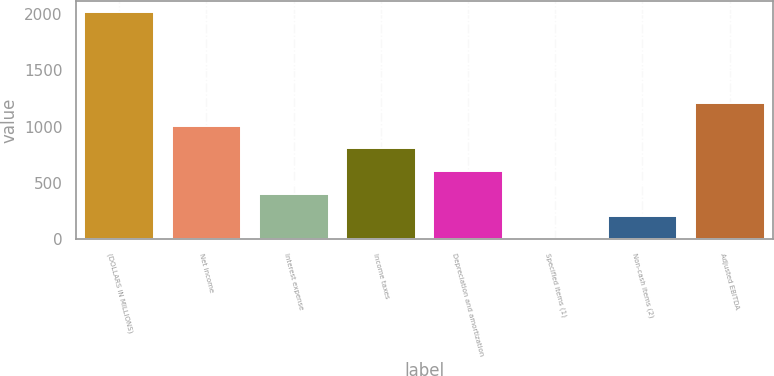Convert chart. <chart><loc_0><loc_0><loc_500><loc_500><bar_chart><fcel>(DOLLARS IN MILLIONS)<fcel>Net income<fcel>Interest expense<fcel>Income taxes<fcel>Depreciation and amortization<fcel>Specified items (1)<fcel>Non-cash items (2)<fcel>Adjusted EBITDA<nl><fcel>2012<fcel>1006.85<fcel>403.76<fcel>805.82<fcel>604.79<fcel>1.7<fcel>202.73<fcel>1207.88<nl></chart> 